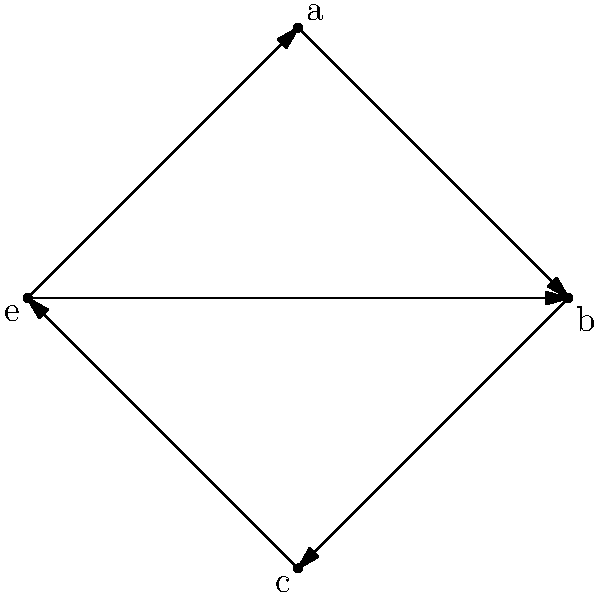In the context of group theory, the graph above represents a group with four elements. Which of the following statements about the group structure is correct based on the visualization?

a) The group is cyclic
b) The group is isomorphic to $\mathbb{Z}_4$
c) The group is isomorphic to Klein four-group
d) The group has no inverse elements To determine the correct statement about the group structure, let's analyze the graph step-by-step:

1. The graph has 4 vertices, representing the 4 elements of the group: e, a, b, and c.

2. The element 'e' is connected to all other elements, indicating it's likely the identity element.

3. Each element has an arrow pointing back to itself, which is consistent with the property that every element composed with itself an even number of times returns to the identity.

4. The graph shows that a * b = c, b * c = a, and c * a = b (following the arrows).

5. This structure doesn't form a cycle (a -> b -> c -> a), ruling out option (a) and (b).

6. The graph shows that each non-identity element (a, b, c) is its own inverse, as composing it with itself leads back to the identity 'e'.

7. This structure, where each non-identity element is its own inverse and the product of any two non-identity elements gives the third, is characteristic of the Klein four-group.

8. The Klein four-group is not cyclic and is not isomorphic to $\mathbb{Z}_4$.

9. All elements have inverses (themselves), so option (d) is incorrect.

Therefore, the correct statement is that the group is isomorphic to the Klein four-group.
Answer: c) The group is isomorphic to Klein four-group 